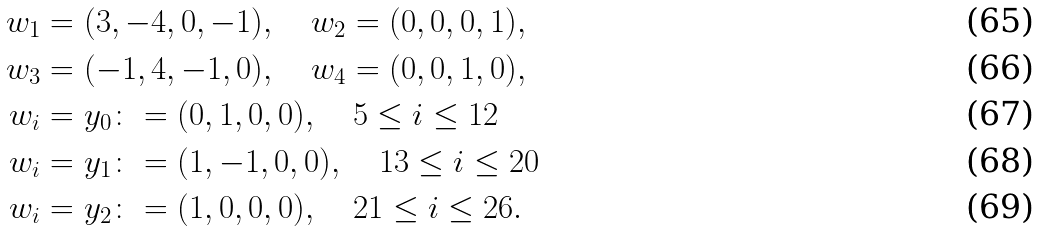<formula> <loc_0><loc_0><loc_500><loc_500>w _ { 1 } & = ( 3 , - 4 , 0 , - 1 ) , \quad w _ { 2 } = ( 0 , 0 , 0 , 1 ) , \\ w _ { 3 } & = ( - 1 , 4 , - 1 , 0 ) , \quad w _ { 4 } = ( 0 , 0 , 1 , 0 ) , \\ w _ { i } & = y _ { 0 } \colon = ( 0 , 1 , 0 , 0 ) , \quad 5 \leq i \leq 1 2 \\ w _ { i } & = y _ { 1 } \colon = ( 1 , - 1 , 0 , 0 ) , \quad 1 3 \leq i \leq 2 0 \\ w _ { i } & = y _ { 2 } \colon = ( 1 , 0 , 0 , 0 ) , \quad 2 1 \leq i \leq 2 6 .</formula> 